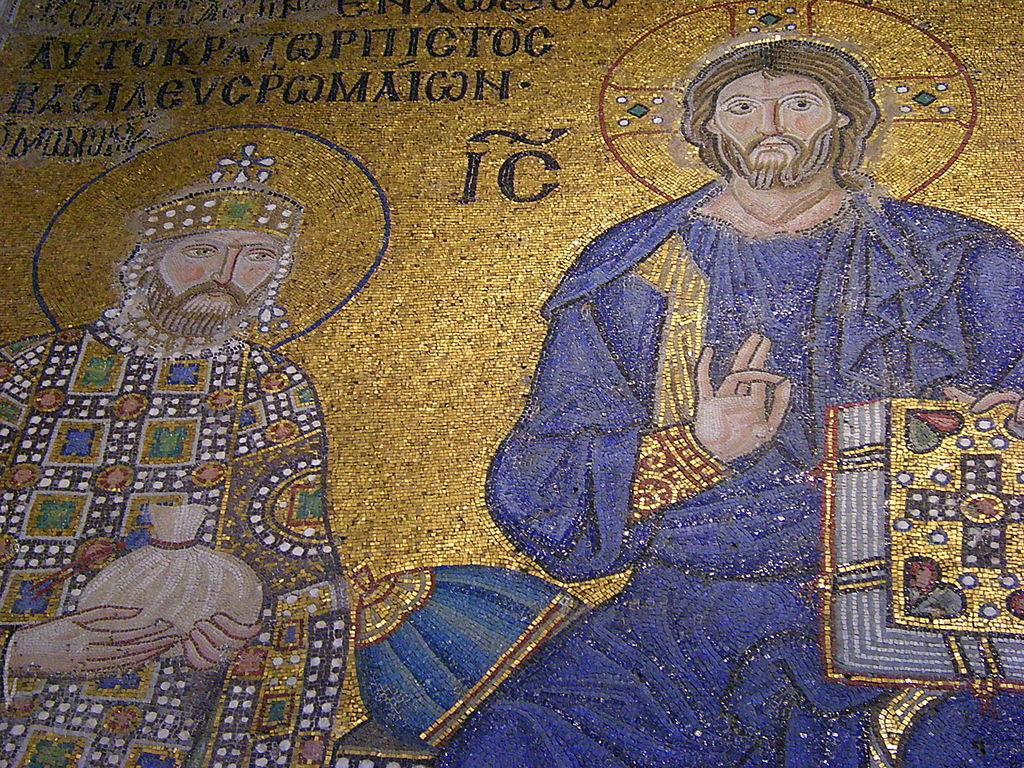Describe this image in one or two sentences. In this picture we can see the painting and some words on the wall. 